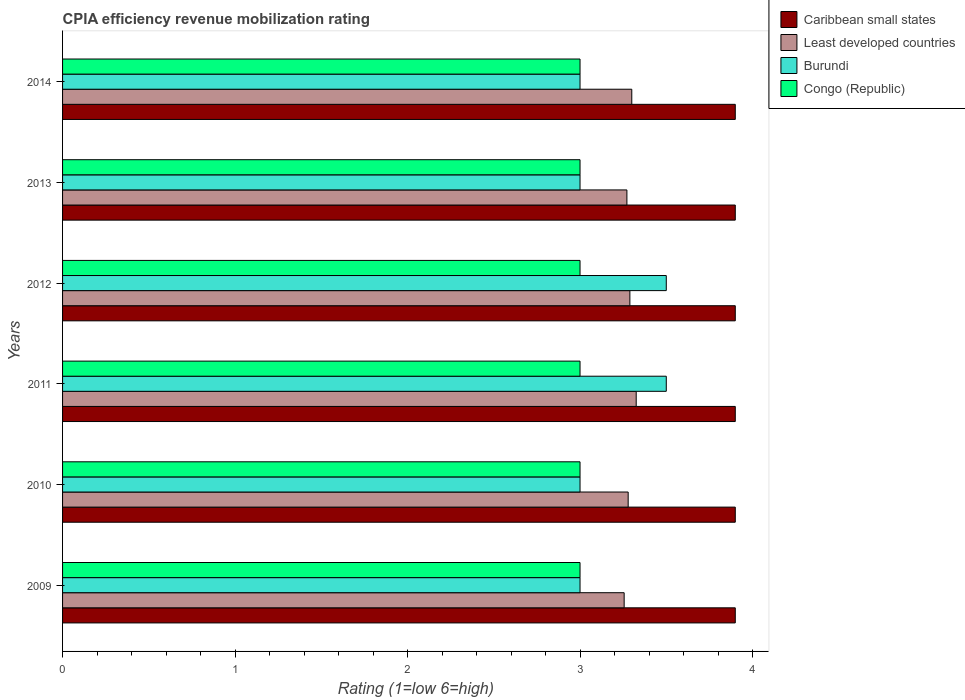Are the number of bars per tick equal to the number of legend labels?
Your answer should be compact. Yes. How many bars are there on the 6th tick from the top?
Offer a very short reply. 4. How many bars are there on the 4th tick from the bottom?
Make the answer very short. 4. What is the label of the 6th group of bars from the top?
Offer a terse response. 2009. In how many cases, is the number of bars for a given year not equal to the number of legend labels?
Your response must be concise. 0. What is the CPIA rating in Least developed countries in 2011?
Offer a terse response. 3.33. In which year was the CPIA rating in Caribbean small states maximum?
Your answer should be very brief. 2009. In which year was the CPIA rating in Caribbean small states minimum?
Your response must be concise. 2009. What is the total CPIA rating in Least developed countries in the graph?
Ensure brevity in your answer.  19.72. What is the difference between the CPIA rating in Burundi in 2010 and that in 2012?
Your answer should be very brief. -0.5. What is the difference between the CPIA rating in Caribbean small states in 2011 and the CPIA rating in Congo (Republic) in 2014?
Ensure brevity in your answer.  0.9. In the year 2011, what is the difference between the CPIA rating in Least developed countries and CPIA rating in Congo (Republic)?
Offer a terse response. 0.33. In how many years, is the CPIA rating in Burundi greater than 3.8 ?
Offer a terse response. 0. What is the ratio of the CPIA rating in Burundi in 2012 to that in 2013?
Ensure brevity in your answer.  1.17. What is the difference between the highest and the second highest CPIA rating in Caribbean small states?
Offer a terse response. 0. What is the difference between the highest and the lowest CPIA rating in Least developed countries?
Make the answer very short. 0.07. What does the 2nd bar from the top in 2011 represents?
Give a very brief answer. Burundi. What does the 2nd bar from the bottom in 2009 represents?
Provide a short and direct response. Least developed countries. Is it the case that in every year, the sum of the CPIA rating in Congo (Republic) and CPIA rating in Burundi is greater than the CPIA rating in Least developed countries?
Ensure brevity in your answer.  Yes. How many bars are there?
Your answer should be compact. 24. Are all the bars in the graph horizontal?
Provide a succinct answer. Yes. How many years are there in the graph?
Provide a succinct answer. 6. Does the graph contain grids?
Keep it short and to the point. No. What is the title of the graph?
Make the answer very short. CPIA efficiency revenue mobilization rating. What is the label or title of the Y-axis?
Ensure brevity in your answer.  Years. What is the Rating (1=low 6=high) in Caribbean small states in 2009?
Offer a terse response. 3.9. What is the Rating (1=low 6=high) in Least developed countries in 2009?
Your answer should be compact. 3.26. What is the Rating (1=low 6=high) in Burundi in 2009?
Ensure brevity in your answer.  3. What is the Rating (1=low 6=high) of Caribbean small states in 2010?
Ensure brevity in your answer.  3.9. What is the Rating (1=low 6=high) in Least developed countries in 2010?
Offer a terse response. 3.28. What is the Rating (1=low 6=high) in Burundi in 2010?
Keep it short and to the point. 3. What is the Rating (1=low 6=high) of Congo (Republic) in 2010?
Ensure brevity in your answer.  3. What is the Rating (1=low 6=high) of Least developed countries in 2011?
Ensure brevity in your answer.  3.33. What is the Rating (1=low 6=high) of Burundi in 2011?
Your response must be concise. 3.5. What is the Rating (1=low 6=high) in Congo (Republic) in 2011?
Your answer should be compact. 3. What is the Rating (1=low 6=high) in Least developed countries in 2012?
Give a very brief answer. 3.29. What is the Rating (1=low 6=high) of Burundi in 2012?
Your answer should be compact. 3.5. What is the Rating (1=low 6=high) in Congo (Republic) in 2012?
Provide a succinct answer. 3. What is the Rating (1=low 6=high) of Caribbean small states in 2013?
Offer a terse response. 3.9. What is the Rating (1=low 6=high) of Least developed countries in 2013?
Your response must be concise. 3.27. What is the Rating (1=low 6=high) of Burundi in 2013?
Your response must be concise. 3. What is the Rating (1=low 6=high) in Caribbean small states in 2014?
Offer a very short reply. 3.9. What is the Rating (1=low 6=high) in Burundi in 2014?
Provide a succinct answer. 3. What is the Rating (1=low 6=high) of Congo (Republic) in 2014?
Your response must be concise. 3. Across all years, what is the maximum Rating (1=low 6=high) in Caribbean small states?
Provide a short and direct response. 3.9. Across all years, what is the maximum Rating (1=low 6=high) of Least developed countries?
Keep it short and to the point. 3.33. Across all years, what is the maximum Rating (1=low 6=high) in Burundi?
Provide a succinct answer. 3.5. Across all years, what is the minimum Rating (1=low 6=high) of Least developed countries?
Offer a terse response. 3.26. Across all years, what is the minimum Rating (1=low 6=high) of Burundi?
Keep it short and to the point. 3. What is the total Rating (1=low 6=high) in Caribbean small states in the graph?
Make the answer very short. 23.4. What is the total Rating (1=low 6=high) in Least developed countries in the graph?
Provide a short and direct response. 19.72. What is the total Rating (1=low 6=high) in Congo (Republic) in the graph?
Offer a terse response. 18. What is the difference between the Rating (1=low 6=high) in Caribbean small states in 2009 and that in 2010?
Offer a terse response. 0. What is the difference between the Rating (1=low 6=high) in Least developed countries in 2009 and that in 2010?
Ensure brevity in your answer.  -0.02. What is the difference between the Rating (1=low 6=high) of Least developed countries in 2009 and that in 2011?
Your answer should be compact. -0.07. What is the difference between the Rating (1=low 6=high) of Burundi in 2009 and that in 2011?
Your answer should be very brief. -0.5. What is the difference between the Rating (1=low 6=high) in Least developed countries in 2009 and that in 2012?
Provide a short and direct response. -0.03. What is the difference between the Rating (1=low 6=high) of Burundi in 2009 and that in 2012?
Keep it short and to the point. -0.5. What is the difference between the Rating (1=low 6=high) in Least developed countries in 2009 and that in 2013?
Your answer should be compact. -0.02. What is the difference between the Rating (1=low 6=high) of Least developed countries in 2009 and that in 2014?
Provide a short and direct response. -0.04. What is the difference between the Rating (1=low 6=high) of Burundi in 2009 and that in 2014?
Ensure brevity in your answer.  0. What is the difference between the Rating (1=low 6=high) of Caribbean small states in 2010 and that in 2011?
Provide a short and direct response. 0. What is the difference between the Rating (1=low 6=high) of Least developed countries in 2010 and that in 2011?
Your answer should be very brief. -0.05. What is the difference between the Rating (1=low 6=high) in Burundi in 2010 and that in 2011?
Your answer should be compact. -0.5. What is the difference between the Rating (1=low 6=high) in Least developed countries in 2010 and that in 2012?
Provide a succinct answer. -0.01. What is the difference between the Rating (1=low 6=high) of Caribbean small states in 2010 and that in 2013?
Your response must be concise. 0. What is the difference between the Rating (1=low 6=high) of Least developed countries in 2010 and that in 2013?
Keep it short and to the point. 0.01. What is the difference between the Rating (1=low 6=high) of Burundi in 2010 and that in 2013?
Keep it short and to the point. 0. What is the difference between the Rating (1=low 6=high) of Congo (Republic) in 2010 and that in 2013?
Your answer should be compact. 0. What is the difference between the Rating (1=low 6=high) of Caribbean small states in 2010 and that in 2014?
Your answer should be very brief. 0. What is the difference between the Rating (1=low 6=high) in Least developed countries in 2010 and that in 2014?
Your answer should be compact. -0.02. What is the difference between the Rating (1=low 6=high) in Congo (Republic) in 2010 and that in 2014?
Offer a terse response. 0. What is the difference between the Rating (1=low 6=high) of Caribbean small states in 2011 and that in 2012?
Provide a short and direct response. 0. What is the difference between the Rating (1=low 6=high) in Least developed countries in 2011 and that in 2012?
Keep it short and to the point. 0.04. What is the difference between the Rating (1=low 6=high) of Burundi in 2011 and that in 2012?
Ensure brevity in your answer.  0. What is the difference between the Rating (1=low 6=high) of Congo (Republic) in 2011 and that in 2012?
Provide a succinct answer. 0. What is the difference between the Rating (1=low 6=high) in Caribbean small states in 2011 and that in 2013?
Your answer should be compact. 0. What is the difference between the Rating (1=low 6=high) of Least developed countries in 2011 and that in 2013?
Make the answer very short. 0.05. What is the difference between the Rating (1=low 6=high) in Burundi in 2011 and that in 2013?
Provide a succinct answer. 0.5. What is the difference between the Rating (1=low 6=high) of Congo (Republic) in 2011 and that in 2013?
Your answer should be very brief. 0. What is the difference between the Rating (1=low 6=high) in Caribbean small states in 2011 and that in 2014?
Give a very brief answer. 0. What is the difference between the Rating (1=low 6=high) in Least developed countries in 2011 and that in 2014?
Keep it short and to the point. 0.03. What is the difference between the Rating (1=low 6=high) of Congo (Republic) in 2011 and that in 2014?
Make the answer very short. 0. What is the difference between the Rating (1=low 6=high) of Least developed countries in 2012 and that in 2013?
Your response must be concise. 0.02. What is the difference between the Rating (1=low 6=high) of Least developed countries in 2012 and that in 2014?
Offer a terse response. -0.01. What is the difference between the Rating (1=low 6=high) of Caribbean small states in 2013 and that in 2014?
Your answer should be very brief. 0. What is the difference between the Rating (1=low 6=high) in Least developed countries in 2013 and that in 2014?
Your answer should be very brief. -0.03. What is the difference between the Rating (1=low 6=high) of Burundi in 2013 and that in 2014?
Your response must be concise. 0. What is the difference between the Rating (1=low 6=high) of Caribbean small states in 2009 and the Rating (1=low 6=high) of Least developed countries in 2010?
Provide a succinct answer. 0.62. What is the difference between the Rating (1=low 6=high) of Caribbean small states in 2009 and the Rating (1=low 6=high) of Congo (Republic) in 2010?
Your answer should be very brief. 0.9. What is the difference between the Rating (1=low 6=high) of Least developed countries in 2009 and the Rating (1=low 6=high) of Burundi in 2010?
Your answer should be very brief. 0.26. What is the difference between the Rating (1=low 6=high) in Least developed countries in 2009 and the Rating (1=low 6=high) in Congo (Republic) in 2010?
Keep it short and to the point. 0.26. What is the difference between the Rating (1=low 6=high) in Caribbean small states in 2009 and the Rating (1=low 6=high) in Least developed countries in 2011?
Your answer should be very brief. 0.57. What is the difference between the Rating (1=low 6=high) of Caribbean small states in 2009 and the Rating (1=low 6=high) of Burundi in 2011?
Your response must be concise. 0.4. What is the difference between the Rating (1=low 6=high) of Least developed countries in 2009 and the Rating (1=low 6=high) of Burundi in 2011?
Ensure brevity in your answer.  -0.24. What is the difference between the Rating (1=low 6=high) of Least developed countries in 2009 and the Rating (1=low 6=high) of Congo (Republic) in 2011?
Keep it short and to the point. 0.26. What is the difference between the Rating (1=low 6=high) of Caribbean small states in 2009 and the Rating (1=low 6=high) of Least developed countries in 2012?
Your answer should be compact. 0.61. What is the difference between the Rating (1=low 6=high) of Caribbean small states in 2009 and the Rating (1=low 6=high) of Burundi in 2012?
Provide a short and direct response. 0.4. What is the difference between the Rating (1=low 6=high) in Least developed countries in 2009 and the Rating (1=low 6=high) in Burundi in 2012?
Your answer should be compact. -0.24. What is the difference between the Rating (1=low 6=high) in Least developed countries in 2009 and the Rating (1=low 6=high) in Congo (Republic) in 2012?
Offer a terse response. 0.26. What is the difference between the Rating (1=low 6=high) in Caribbean small states in 2009 and the Rating (1=low 6=high) in Least developed countries in 2013?
Make the answer very short. 0.63. What is the difference between the Rating (1=low 6=high) in Caribbean small states in 2009 and the Rating (1=low 6=high) in Burundi in 2013?
Give a very brief answer. 0.9. What is the difference between the Rating (1=low 6=high) of Caribbean small states in 2009 and the Rating (1=low 6=high) of Congo (Republic) in 2013?
Keep it short and to the point. 0.9. What is the difference between the Rating (1=low 6=high) of Least developed countries in 2009 and the Rating (1=low 6=high) of Burundi in 2013?
Your answer should be very brief. 0.26. What is the difference between the Rating (1=low 6=high) of Least developed countries in 2009 and the Rating (1=low 6=high) of Congo (Republic) in 2013?
Provide a short and direct response. 0.26. What is the difference between the Rating (1=low 6=high) of Burundi in 2009 and the Rating (1=low 6=high) of Congo (Republic) in 2013?
Make the answer very short. 0. What is the difference between the Rating (1=low 6=high) in Caribbean small states in 2009 and the Rating (1=low 6=high) in Burundi in 2014?
Make the answer very short. 0.9. What is the difference between the Rating (1=low 6=high) in Caribbean small states in 2009 and the Rating (1=low 6=high) in Congo (Republic) in 2014?
Give a very brief answer. 0.9. What is the difference between the Rating (1=low 6=high) in Least developed countries in 2009 and the Rating (1=low 6=high) in Burundi in 2014?
Keep it short and to the point. 0.26. What is the difference between the Rating (1=low 6=high) in Least developed countries in 2009 and the Rating (1=low 6=high) in Congo (Republic) in 2014?
Your answer should be very brief. 0.26. What is the difference between the Rating (1=low 6=high) of Caribbean small states in 2010 and the Rating (1=low 6=high) of Least developed countries in 2011?
Keep it short and to the point. 0.57. What is the difference between the Rating (1=low 6=high) in Caribbean small states in 2010 and the Rating (1=low 6=high) in Congo (Republic) in 2011?
Make the answer very short. 0.9. What is the difference between the Rating (1=low 6=high) in Least developed countries in 2010 and the Rating (1=low 6=high) in Burundi in 2011?
Your answer should be very brief. -0.22. What is the difference between the Rating (1=low 6=high) in Least developed countries in 2010 and the Rating (1=low 6=high) in Congo (Republic) in 2011?
Your answer should be very brief. 0.28. What is the difference between the Rating (1=low 6=high) of Burundi in 2010 and the Rating (1=low 6=high) of Congo (Republic) in 2011?
Your response must be concise. 0. What is the difference between the Rating (1=low 6=high) of Caribbean small states in 2010 and the Rating (1=low 6=high) of Least developed countries in 2012?
Give a very brief answer. 0.61. What is the difference between the Rating (1=low 6=high) of Caribbean small states in 2010 and the Rating (1=low 6=high) of Burundi in 2012?
Provide a succinct answer. 0.4. What is the difference between the Rating (1=low 6=high) in Least developed countries in 2010 and the Rating (1=low 6=high) in Burundi in 2012?
Provide a short and direct response. -0.22. What is the difference between the Rating (1=low 6=high) in Least developed countries in 2010 and the Rating (1=low 6=high) in Congo (Republic) in 2012?
Keep it short and to the point. 0.28. What is the difference between the Rating (1=low 6=high) of Burundi in 2010 and the Rating (1=low 6=high) of Congo (Republic) in 2012?
Offer a terse response. 0. What is the difference between the Rating (1=low 6=high) in Caribbean small states in 2010 and the Rating (1=low 6=high) in Least developed countries in 2013?
Keep it short and to the point. 0.63. What is the difference between the Rating (1=low 6=high) of Least developed countries in 2010 and the Rating (1=low 6=high) of Burundi in 2013?
Give a very brief answer. 0.28. What is the difference between the Rating (1=low 6=high) in Least developed countries in 2010 and the Rating (1=low 6=high) in Congo (Republic) in 2013?
Your answer should be very brief. 0.28. What is the difference between the Rating (1=low 6=high) in Caribbean small states in 2010 and the Rating (1=low 6=high) in Burundi in 2014?
Provide a short and direct response. 0.9. What is the difference between the Rating (1=low 6=high) in Caribbean small states in 2010 and the Rating (1=low 6=high) in Congo (Republic) in 2014?
Your answer should be very brief. 0.9. What is the difference between the Rating (1=low 6=high) in Least developed countries in 2010 and the Rating (1=low 6=high) in Burundi in 2014?
Provide a succinct answer. 0.28. What is the difference between the Rating (1=low 6=high) in Least developed countries in 2010 and the Rating (1=low 6=high) in Congo (Republic) in 2014?
Make the answer very short. 0.28. What is the difference between the Rating (1=low 6=high) of Burundi in 2010 and the Rating (1=low 6=high) of Congo (Republic) in 2014?
Offer a terse response. 0. What is the difference between the Rating (1=low 6=high) in Caribbean small states in 2011 and the Rating (1=low 6=high) in Least developed countries in 2012?
Provide a succinct answer. 0.61. What is the difference between the Rating (1=low 6=high) in Caribbean small states in 2011 and the Rating (1=low 6=high) in Congo (Republic) in 2012?
Provide a succinct answer. 0.9. What is the difference between the Rating (1=low 6=high) of Least developed countries in 2011 and the Rating (1=low 6=high) of Burundi in 2012?
Ensure brevity in your answer.  -0.17. What is the difference between the Rating (1=low 6=high) of Least developed countries in 2011 and the Rating (1=low 6=high) of Congo (Republic) in 2012?
Offer a very short reply. 0.33. What is the difference between the Rating (1=low 6=high) of Burundi in 2011 and the Rating (1=low 6=high) of Congo (Republic) in 2012?
Ensure brevity in your answer.  0.5. What is the difference between the Rating (1=low 6=high) of Caribbean small states in 2011 and the Rating (1=low 6=high) of Least developed countries in 2013?
Ensure brevity in your answer.  0.63. What is the difference between the Rating (1=low 6=high) in Least developed countries in 2011 and the Rating (1=low 6=high) in Burundi in 2013?
Offer a very short reply. 0.33. What is the difference between the Rating (1=low 6=high) of Least developed countries in 2011 and the Rating (1=low 6=high) of Congo (Republic) in 2013?
Offer a very short reply. 0.33. What is the difference between the Rating (1=low 6=high) in Burundi in 2011 and the Rating (1=low 6=high) in Congo (Republic) in 2013?
Your answer should be very brief. 0.5. What is the difference between the Rating (1=low 6=high) in Caribbean small states in 2011 and the Rating (1=low 6=high) in Burundi in 2014?
Your answer should be compact. 0.9. What is the difference between the Rating (1=low 6=high) in Caribbean small states in 2011 and the Rating (1=low 6=high) in Congo (Republic) in 2014?
Your answer should be compact. 0.9. What is the difference between the Rating (1=low 6=high) of Least developed countries in 2011 and the Rating (1=low 6=high) of Burundi in 2014?
Your response must be concise. 0.33. What is the difference between the Rating (1=low 6=high) in Least developed countries in 2011 and the Rating (1=low 6=high) in Congo (Republic) in 2014?
Make the answer very short. 0.33. What is the difference between the Rating (1=low 6=high) of Burundi in 2011 and the Rating (1=low 6=high) of Congo (Republic) in 2014?
Ensure brevity in your answer.  0.5. What is the difference between the Rating (1=low 6=high) in Caribbean small states in 2012 and the Rating (1=low 6=high) in Least developed countries in 2013?
Offer a terse response. 0.63. What is the difference between the Rating (1=low 6=high) in Least developed countries in 2012 and the Rating (1=low 6=high) in Burundi in 2013?
Provide a succinct answer. 0.29. What is the difference between the Rating (1=low 6=high) of Least developed countries in 2012 and the Rating (1=low 6=high) of Congo (Republic) in 2013?
Your answer should be very brief. 0.29. What is the difference between the Rating (1=low 6=high) of Burundi in 2012 and the Rating (1=low 6=high) of Congo (Republic) in 2013?
Your answer should be compact. 0.5. What is the difference between the Rating (1=low 6=high) in Caribbean small states in 2012 and the Rating (1=low 6=high) in Burundi in 2014?
Provide a succinct answer. 0.9. What is the difference between the Rating (1=low 6=high) of Caribbean small states in 2012 and the Rating (1=low 6=high) of Congo (Republic) in 2014?
Offer a terse response. 0.9. What is the difference between the Rating (1=low 6=high) in Least developed countries in 2012 and the Rating (1=low 6=high) in Burundi in 2014?
Ensure brevity in your answer.  0.29. What is the difference between the Rating (1=low 6=high) in Least developed countries in 2012 and the Rating (1=low 6=high) in Congo (Republic) in 2014?
Your answer should be very brief. 0.29. What is the difference between the Rating (1=low 6=high) of Caribbean small states in 2013 and the Rating (1=low 6=high) of Burundi in 2014?
Provide a succinct answer. 0.9. What is the difference between the Rating (1=low 6=high) of Caribbean small states in 2013 and the Rating (1=low 6=high) of Congo (Republic) in 2014?
Give a very brief answer. 0.9. What is the difference between the Rating (1=low 6=high) in Least developed countries in 2013 and the Rating (1=low 6=high) in Burundi in 2014?
Your answer should be compact. 0.27. What is the difference between the Rating (1=low 6=high) of Least developed countries in 2013 and the Rating (1=low 6=high) of Congo (Republic) in 2014?
Make the answer very short. 0.27. What is the average Rating (1=low 6=high) of Caribbean small states per year?
Your answer should be compact. 3.9. What is the average Rating (1=low 6=high) in Least developed countries per year?
Provide a succinct answer. 3.29. What is the average Rating (1=low 6=high) of Burundi per year?
Provide a succinct answer. 3.17. In the year 2009, what is the difference between the Rating (1=low 6=high) in Caribbean small states and Rating (1=low 6=high) in Least developed countries?
Provide a succinct answer. 0.64. In the year 2009, what is the difference between the Rating (1=low 6=high) in Caribbean small states and Rating (1=low 6=high) in Burundi?
Ensure brevity in your answer.  0.9. In the year 2009, what is the difference between the Rating (1=low 6=high) of Least developed countries and Rating (1=low 6=high) of Burundi?
Offer a very short reply. 0.26. In the year 2009, what is the difference between the Rating (1=low 6=high) of Least developed countries and Rating (1=low 6=high) of Congo (Republic)?
Your response must be concise. 0.26. In the year 2009, what is the difference between the Rating (1=low 6=high) of Burundi and Rating (1=low 6=high) of Congo (Republic)?
Ensure brevity in your answer.  0. In the year 2010, what is the difference between the Rating (1=low 6=high) of Caribbean small states and Rating (1=low 6=high) of Least developed countries?
Your answer should be compact. 0.62. In the year 2010, what is the difference between the Rating (1=low 6=high) of Caribbean small states and Rating (1=low 6=high) of Congo (Republic)?
Ensure brevity in your answer.  0.9. In the year 2010, what is the difference between the Rating (1=low 6=high) of Least developed countries and Rating (1=low 6=high) of Burundi?
Offer a very short reply. 0.28. In the year 2010, what is the difference between the Rating (1=low 6=high) in Least developed countries and Rating (1=low 6=high) in Congo (Republic)?
Offer a very short reply. 0.28. In the year 2010, what is the difference between the Rating (1=low 6=high) of Burundi and Rating (1=low 6=high) of Congo (Republic)?
Your answer should be very brief. 0. In the year 2011, what is the difference between the Rating (1=low 6=high) in Caribbean small states and Rating (1=low 6=high) in Least developed countries?
Your answer should be very brief. 0.57. In the year 2011, what is the difference between the Rating (1=low 6=high) of Least developed countries and Rating (1=low 6=high) of Burundi?
Your answer should be very brief. -0.17. In the year 2011, what is the difference between the Rating (1=low 6=high) in Least developed countries and Rating (1=low 6=high) in Congo (Republic)?
Provide a short and direct response. 0.33. In the year 2012, what is the difference between the Rating (1=low 6=high) of Caribbean small states and Rating (1=low 6=high) of Least developed countries?
Keep it short and to the point. 0.61. In the year 2012, what is the difference between the Rating (1=low 6=high) of Caribbean small states and Rating (1=low 6=high) of Burundi?
Provide a succinct answer. 0.4. In the year 2012, what is the difference between the Rating (1=low 6=high) of Least developed countries and Rating (1=low 6=high) of Burundi?
Offer a very short reply. -0.21. In the year 2012, what is the difference between the Rating (1=low 6=high) of Least developed countries and Rating (1=low 6=high) of Congo (Republic)?
Provide a succinct answer. 0.29. In the year 2012, what is the difference between the Rating (1=low 6=high) of Burundi and Rating (1=low 6=high) of Congo (Republic)?
Your answer should be very brief. 0.5. In the year 2013, what is the difference between the Rating (1=low 6=high) in Caribbean small states and Rating (1=low 6=high) in Least developed countries?
Make the answer very short. 0.63. In the year 2013, what is the difference between the Rating (1=low 6=high) of Caribbean small states and Rating (1=low 6=high) of Burundi?
Provide a short and direct response. 0.9. In the year 2013, what is the difference between the Rating (1=low 6=high) in Least developed countries and Rating (1=low 6=high) in Burundi?
Keep it short and to the point. 0.27. In the year 2013, what is the difference between the Rating (1=low 6=high) in Least developed countries and Rating (1=low 6=high) in Congo (Republic)?
Offer a terse response. 0.27. In the year 2013, what is the difference between the Rating (1=low 6=high) in Burundi and Rating (1=low 6=high) in Congo (Republic)?
Offer a very short reply. 0. In the year 2014, what is the difference between the Rating (1=low 6=high) of Caribbean small states and Rating (1=low 6=high) of Least developed countries?
Your response must be concise. 0.6. In the year 2014, what is the difference between the Rating (1=low 6=high) of Caribbean small states and Rating (1=low 6=high) of Burundi?
Your response must be concise. 0.9. In the year 2014, what is the difference between the Rating (1=low 6=high) of Caribbean small states and Rating (1=low 6=high) of Congo (Republic)?
Keep it short and to the point. 0.9. In the year 2014, what is the difference between the Rating (1=low 6=high) in Least developed countries and Rating (1=low 6=high) in Burundi?
Offer a terse response. 0.3. In the year 2014, what is the difference between the Rating (1=low 6=high) in Burundi and Rating (1=low 6=high) in Congo (Republic)?
Ensure brevity in your answer.  0. What is the ratio of the Rating (1=low 6=high) in Burundi in 2009 to that in 2010?
Keep it short and to the point. 1. What is the ratio of the Rating (1=low 6=high) in Congo (Republic) in 2009 to that in 2010?
Your answer should be very brief. 1. What is the ratio of the Rating (1=low 6=high) of Congo (Republic) in 2009 to that in 2011?
Make the answer very short. 1. What is the ratio of the Rating (1=low 6=high) in Caribbean small states in 2009 to that in 2012?
Ensure brevity in your answer.  1. What is the ratio of the Rating (1=low 6=high) of Least developed countries in 2009 to that in 2012?
Provide a succinct answer. 0.99. What is the ratio of the Rating (1=low 6=high) in Burundi in 2009 to that in 2012?
Your answer should be compact. 0.86. What is the ratio of the Rating (1=low 6=high) in Least developed countries in 2009 to that in 2013?
Your answer should be very brief. 1. What is the ratio of the Rating (1=low 6=high) of Burundi in 2009 to that in 2013?
Your response must be concise. 1. What is the ratio of the Rating (1=low 6=high) in Caribbean small states in 2009 to that in 2014?
Your answer should be compact. 1. What is the ratio of the Rating (1=low 6=high) of Least developed countries in 2009 to that in 2014?
Provide a short and direct response. 0.99. What is the ratio of the Rating (1=low 6=high) of Congo (Republic) in 2009 to that in 2014?
Offer a very short reply. 1. What is the ratio of the Rating (1=low 6=high) in Least developed countries in 2010 to that in 2011?
Your answer should be compact. 0.99. What is the ratio of the Rating (1=low 6=high) in Burundi in 2010 to that in 2011?
Offer a terse response. 0.86. What is the ratio of the Rating (1=low 6=high) of Congo (Republic) in 2010 to that in 2011?
Make the answer very short. 1. What is the ratio of the Rating (1=low 6=high) of Least developed countries in 2010 to that in 2013?
Your answer should be very brief. 1. What is the ratio of the Rating (1=low 6=high) of Burundi in 2010 to that in 2013?
Provide a succinct answer. 1. What is the ratio of the Rating (1=low 6=high) of Congo (Republic) in 2010 to that in 2013?
Your answer should be compact. 1. What is the ratio of the Rating (1=low 6=high) in Caribbean small states in 2010 to that in 2014?
Provide a short and direct response. 1. What is the ratio of the Rating (1=low 6=high) in Least developed countries in 2010 to that in 2014?
Keep it short and to the point. 0.99. What is the ratio of the Rating (1=low 6=high) in Congo (Republic) in 2010 to that in 2014?
Give a very brief answer. 1. What is the ratio of the Rating (1=low 6=high) of Caribbean small states in 2011 to that in 2012?
Your answer should be very brief. 1. What is the ratio of the Rating (1=low 6=high) of Least developed countries in 2011 to that in 2012?
Offer a very short reply. 1.01. What is the ratio of the Rating (1=low 6=high) of Burundi in 2011 to that in 2012?
Offer a terse response. 1. What is the ratio of the Rating (1=low 6=high) in Congo (Republic) in 2011 to that in 2012?
Offer a very short reply. 1. What is the ratio of the Rating (1=low 6=high) in Least developed countries in 2011 to that in 2013?
Your answer should be very brief. 1.02. What is the ratio of the Rating (1=low 6=high) in Congo (Republic) in 2011 to that in 2013?
Keep it short and to the point. 1. What is the ratio of the Rating (1=low 6=high) in Caribbean small states in 2012 to that in 2013?
Provide a short and direct response. 1. What is the ratio of the Rating (1=low 6=high) of Burundi in 2012 to that in 2013?
Ensure brevity in your answer.  1.17. What is the ratio of the Rating (1=low 6=high) in Congo (Republic) in 2012 to that in 2013?
Give a very brief answer. 1. What is the ratio of the Rating (1=low 6=high) of Caribbean small states in 2012 to that in 2014?
Ensure brevity in your answer.  1. What is the ratio of the Rating (1=low 6=high) of Congo (Republic) in 2012 to that in 2014?
Keep it short and to the point. 1. What is the ratio of the Rating (1=low 6=high) in Congo (Republic) in 2013 to that in 2014?
Provide a short and direct response. 1. What is the difference between the highest and the second highest Rating (1=low 6=high) of Caribbean small states?
Offer a terse response. 0. What is the difference between the highest and the second highest Rating (1=low 6=high) of Least developed countries?
Your response must be concise. 0.03. What is the difference between the highest and the lowest Rating (1=low 6=high) in Caribbean small states?
Give a very brief answer. 0. What is the difference between the highest and the lowest Rating (1=low 6=high) of Least developed countries?
Your answer should be very brief. 0.07. What is the difference between the highest and the lowest Rating (1=low 6=high) in Burundi?
Your answer should be very brief. 0.5. What is the difference between the highest and the lowest Rating (1=low 6=high) of Congo (Republic)?
Make the answer very short. 0. 